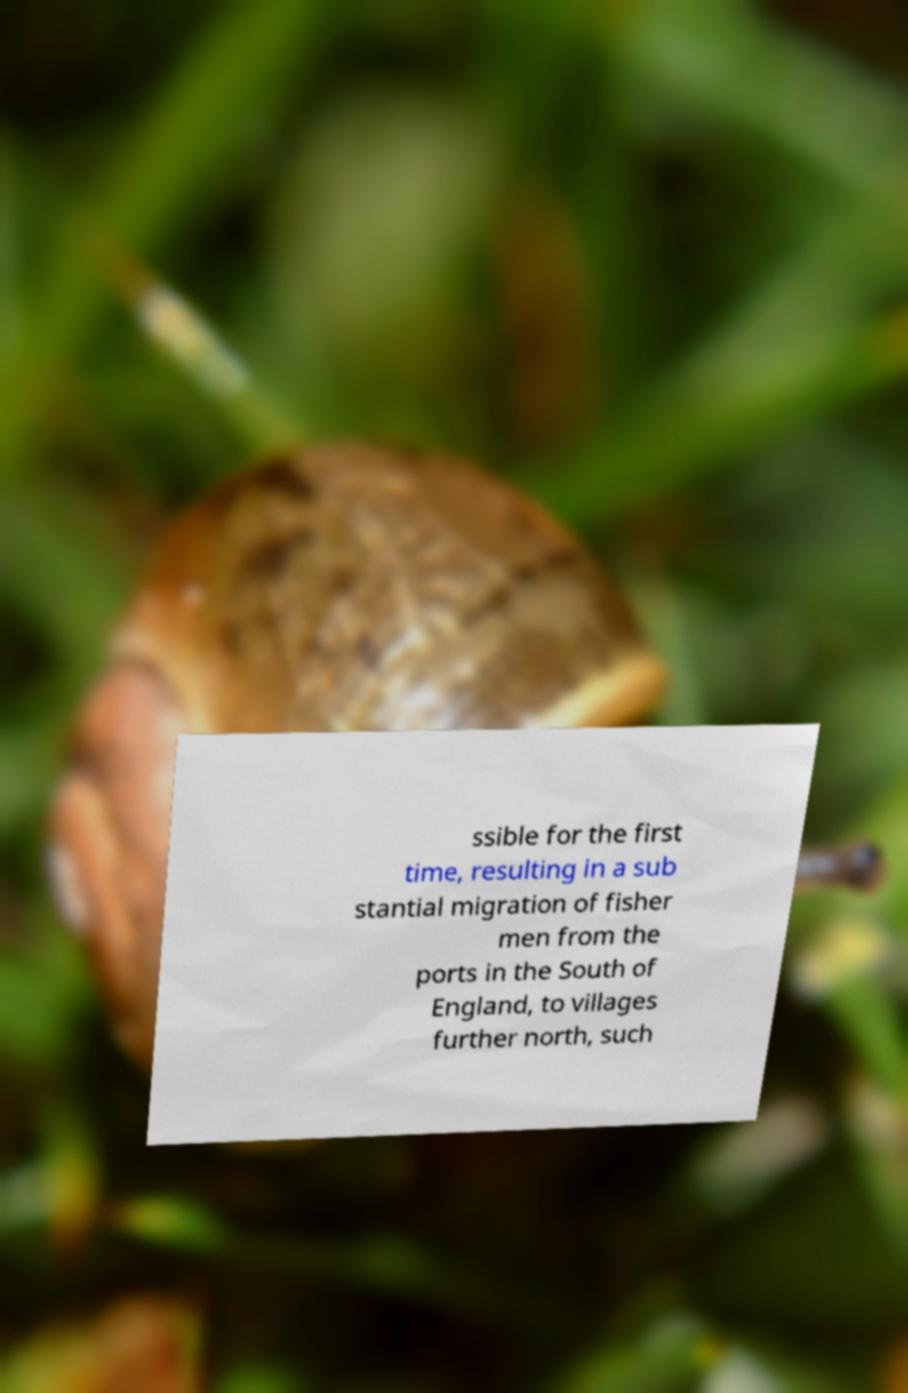Please read and relay the text visible in this image. What does it say? ssible for the first time, resulting in a sub stantial migration of fisher men from the ports in the South of England, to villages further north, such 